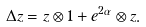Convert formula to latex. <formula><loc_0><loc_0><loc_500><loc_500>\Delta z = z \otimes 1 + e ^ { 2 \alpha } \otimes z .</formula> 